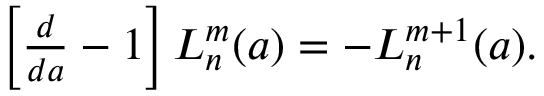Convert formula to latex. <formula><loc_0><loc_0><loc_500><loc_500>\begin{array} { r } { \left [ \frac { d } { d a } - 1 \right ] L _ { n } ^ { m } ( a ) = - L _ { n } ^ { m + 1 } ( a ) . } \end{array}</formula> 